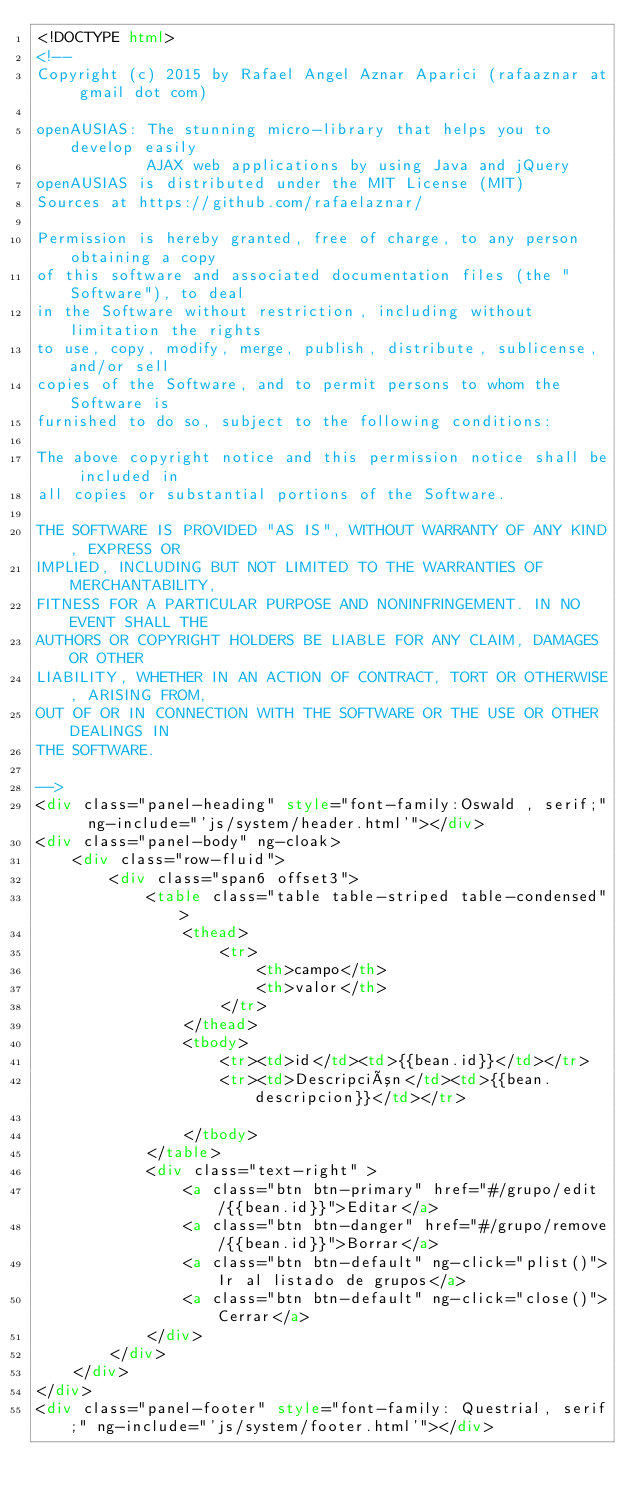Convert code to text. <code><loc_0><loc_0><loc_500><loc_500><_HTML_><!DOCTYPE html>
<!--
Copyright (c) 2015 by Rafael Angel Aznar Aparici (rafaaznar at gmail dot com)

openAUSIAS: The stunning micro-library that helps you to develop easily 
            AJAX web applications by using Java and jQuery
openAUSIAS is distributed under the MIT License (MIT)
Sources at https://github.com/rafaelaznar/

Permission is hereby granted, free of charge, to any person obtaining a copy
of this software and associated documentation files (the "Software"), to deal
in the Software without restriction, including without limitation the rights
to use, copy, modify, merge, publish, distribute, sublicense, and/or sell
copies of the Software, and to permit persons to whom the Software is
furnished to do so, subject to the following conditions:

The above copyright notice and this permission notice shall be included in
all copies or substantial portions of the Software.

THE SOFTWARE IS PROVIDED "AS IS", WITHOUT WARRANTY OF ANY KIND, EXPRESS OR
IMPLIED, INCLUDING BUT NOT LIMITED TO THE WARRANTIES OF MERCHANTABILITY,
FITNESS FOR A PARTICULAR PURPOSE AND NONINFRINGEMENT. IN NO EVENT SHALL THE
AUTHORS OR COPYRIGHT HOLDERS BE LIABLE FOR ANY CLAIM, DAMAGES OR OTHER
LIABILITY, WHETHER IN AN ACTION OF CONTRACT, TORT OR OTHERWISE, ARISING FROM,
OUT OF OR IN CONNECTION WITH THE SOFTWARE OR THE USE OR OTHER DEALINGS IN
THE SOFTWARE.

-->
<div class="panel-heading" style="font-family:Oswald , serif;"  ng-include="'js/system/header.html'"></div>
<div class="panel-body" ng-cloak>
    <div class="row-fluid">
        <div class="span6 offset3">                
            <table class="table table-striped table-condensed">
                <thead>                
                    <tr>    
                        <th>campo</th>
                        <th>valor</th>
                    </tr>
                </thead>
                <tbody>
                    <tr><td>id</td><td>{{bean.id}}</td></tr> 
                    <tr><td>Descripción</td><td>{{bean.descripcion}}</td></tr>
                    
                </tbody>
            </table>  
            <div class="text-right" > 
                <a class="btn btn-primary" href="#/grupo/edit/{{bean.id}}">Editar</a>
                <a class="btn btn-danger" href="#/grupo/remove/{{bean.id}}">Borrar</a>
                <a class="btn btn-default" ng-click="plist()">Ir al listado de grupos</a>
                <a class="btn btn-default" ng-click="close()">Cerrar</a>
            </div>
        </div>
    </div>
</div>
<div class="panel-footer" style="font-family: Questrial, serif;" ng-include="'js/system/footer.html'"></div>
</code> 